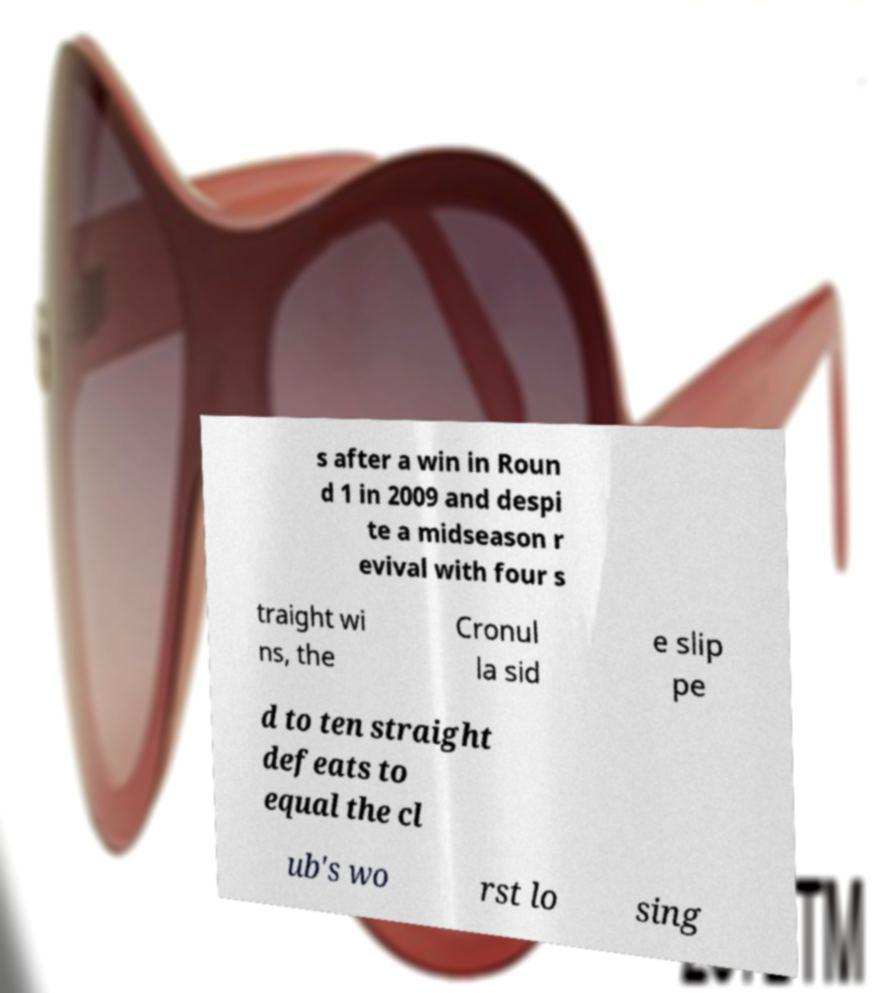Could you assist in decoding the text presented in this image and type it out clearly? s after a win in Roun d 1 in 2009 and despi te a midseason r evival with four s traight wi ns, the Cronul la sid e slip pe d to ten straight defeats to equal the cl ub's wo rst lo sing 